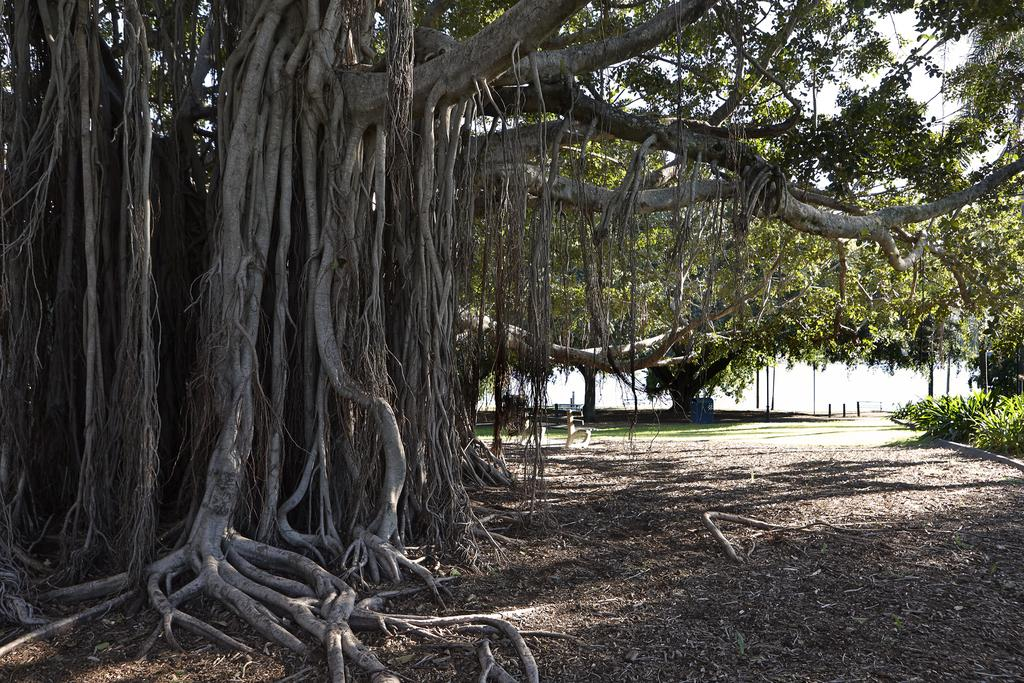What type of vegetation can be seen in the image? There are trees in the image. What type of seating is present in the image? There is an empty bench in the image. What is the ground covered with in the image? There is grass on the ground in the image. What can be seen in the distance in the image? There is water visible in the background of the image. Where is the hall located in the image? There is no hall present in the image. What is the starting point for the journey in the image? The image does not depict a journey or a starting point. 